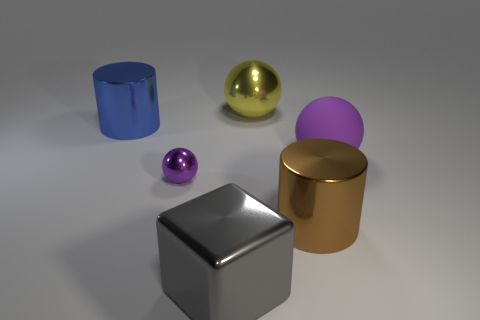What size is the blue thing?
Your answer should be compact. Large. Does the shiny block have the same size as the metallic ball behind the big purple object?
Make the answer very short. Yes. The large thing left of the big gray object that is on the right side of the ball that is in front of the big purple thing is what color?
Your response must be concise. Blue. Is the material of the purple object on the left side of the matte thing the same as the large blue object?
Give a very brief answer. Yes. How many other things are there of the same material as the brown thing?
Make the answer very short. 4. What is the material of the purple sphere that is the same size as the yellow ball?
Offer a very short reply. Rubber. There is a purple thing that is to the right of the gray block; does it have the same shape as the metal thing that is on the left side of the small purple shiny sphere?
Give a very brief answer. No. The blue shiny thing that is the same size as the brown shiny cylinder is what shape?
Your response must be concise. Cylinder. Does the big cylinder that is in front of the purple matte ball have the same material as the purple object that is right of the purple metallic sphere?
Your answer should be very brief. No. Is there a big matte object that is behind the metallic object to the left of the small purple metal thing?
Make the answer very short. No. 